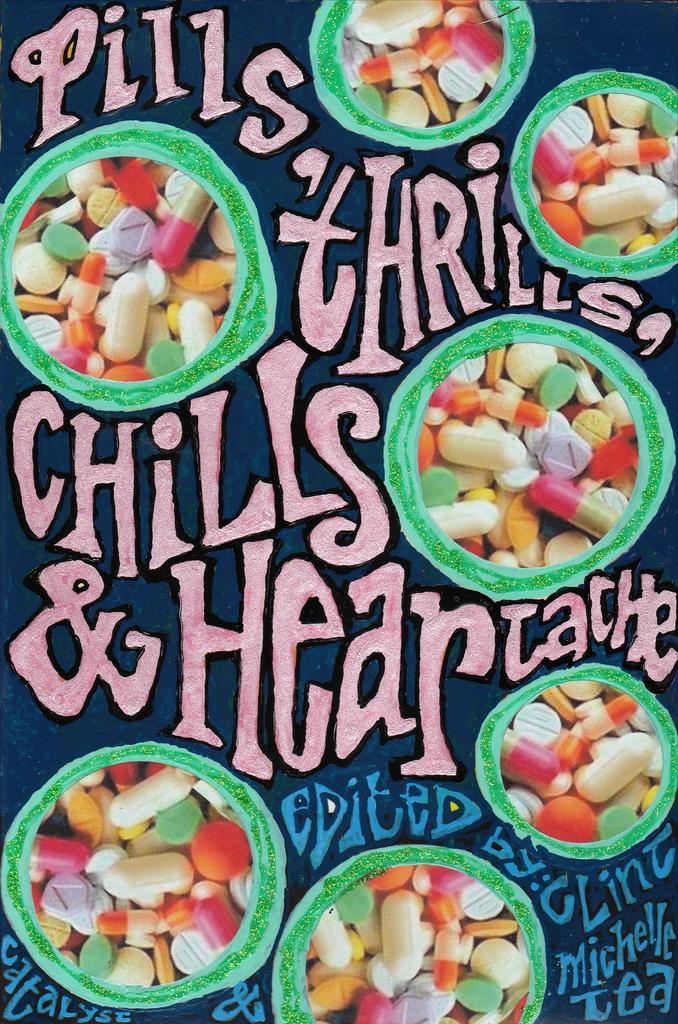Please provide a concise description of this image. The picture is a poster. In the picture there are capsules and tablets. In the picture there are different texts. 